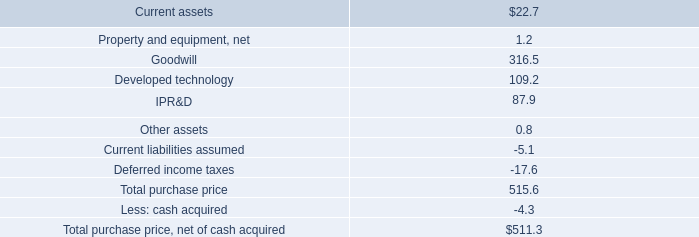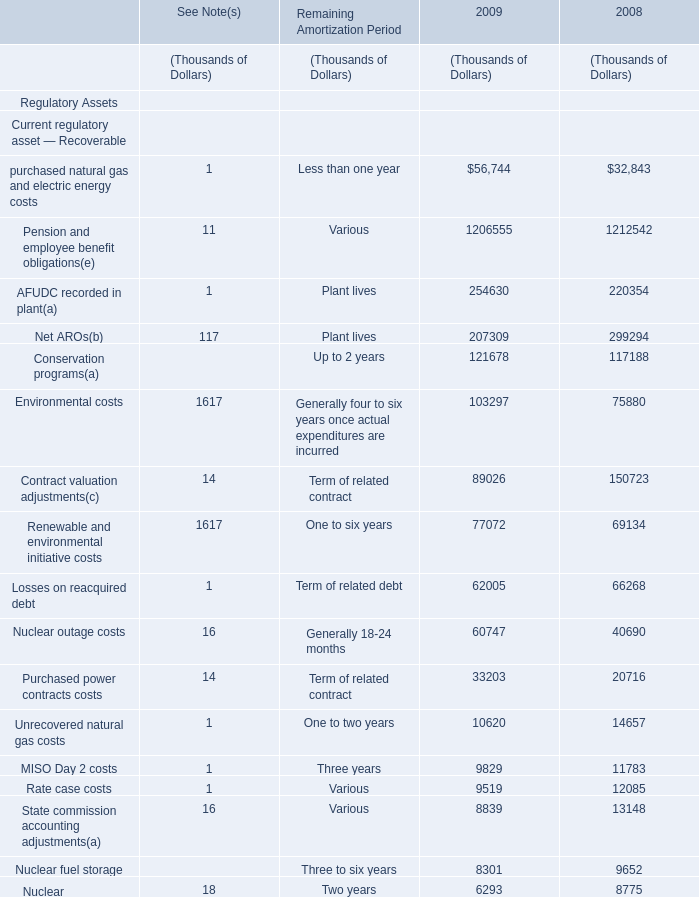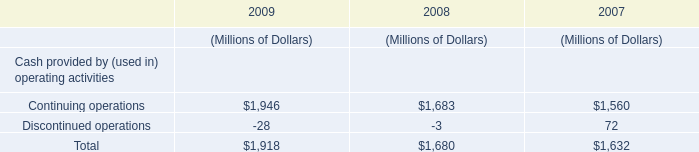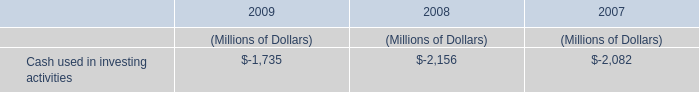When does Total noncurrent regulatory liabilities reach the largest value? 
Answer: 2009. 